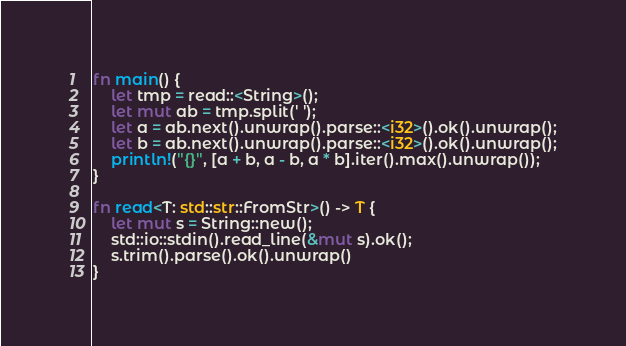Convert code to text. <code><loc_0><loc_0><loc_500><loc_500><_Rust_>fn main() {
    let tmp = read::<String>();
    let mut ab = tmp.split(' ');
    let a = ab.next().unwrap().parse::<i32>().ok().unwrap();
    let b = ab.next().unwrap().parse::<i32>().ok().unwrap();
    println!("{}", [a + b, a - b, a * b].iter().max().unwrap());
}

fn read<T: std::str::FromStr>() -> T {
    let mut s = String::new();
    std::io::stdin().read_line(&mut s).ok();
    s.trim().parse().ok().unwrap()
}
</code> 